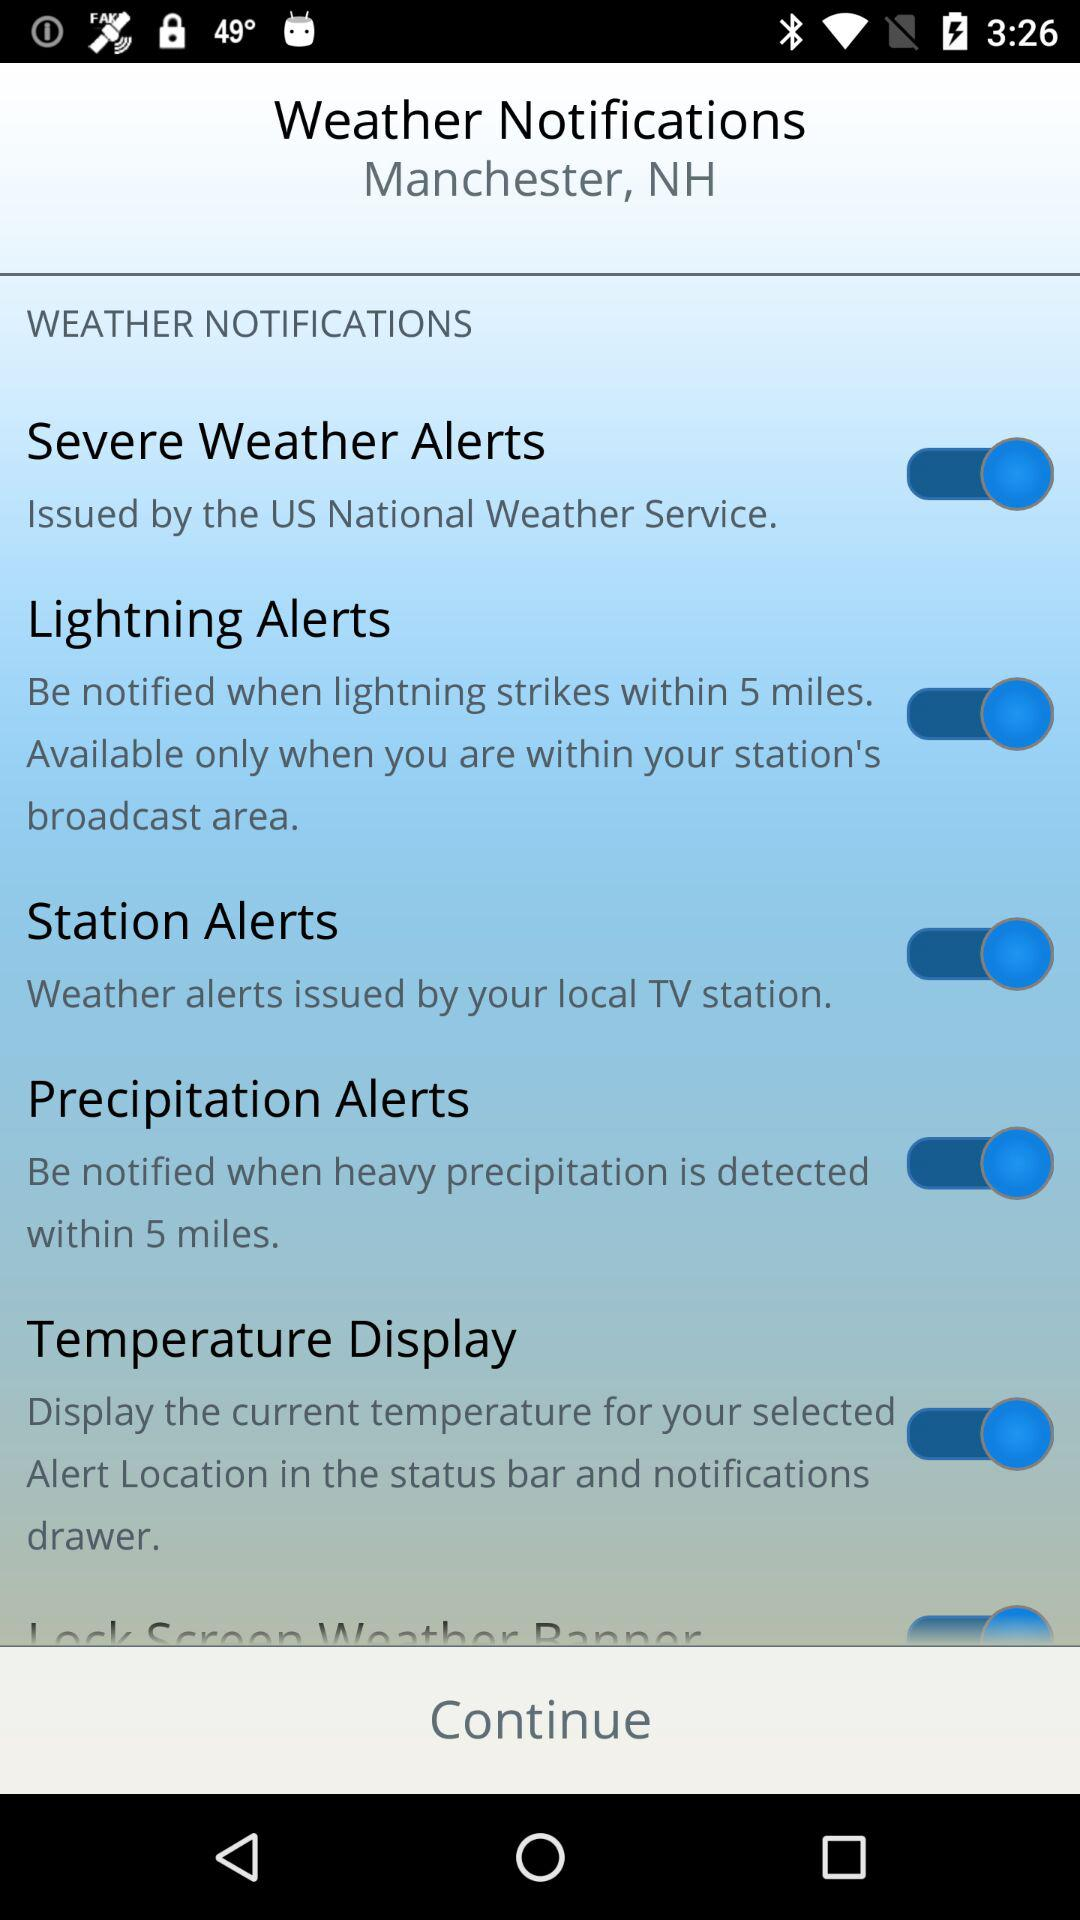What is the location? The location is Manchester, NH. 